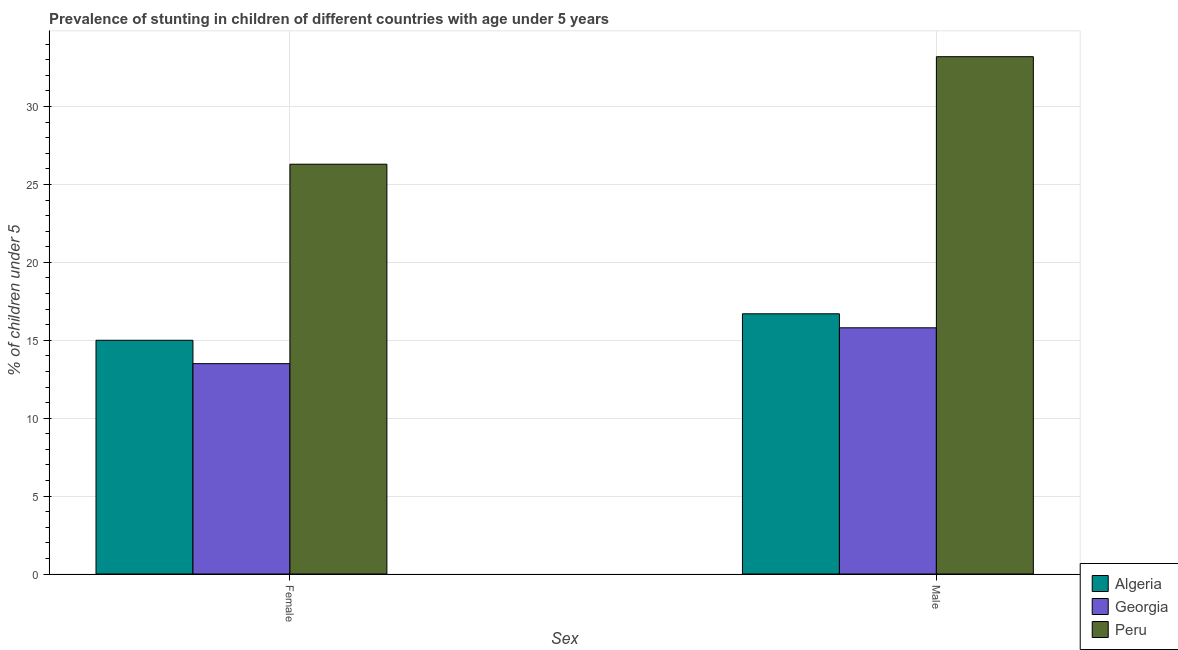How many different coloured bars are there?
Give a very brief answer. 3. How many bars are there on the 1st tick from the left?
Provide a short and direct response. 3. What is the label of the 2nd group of bars from the left?
Provide a short and direct response. Male. What is the percentage of stunted male children in Peru?
Offer a very short reply. 33.2. Across all countries, what is the maximum percentage of stunted female children?
Provide a short and direct response. 26.3. Across all countries, what is the minimum percentage of stunted male children?
Your answer should be very brief. 15.8. In which country was the percentage of stunted male children maximum?
Your answer should be very brief. Peru. In which country was the percentage of stunted female children minimum?
Your answer should be very brief. Georgia. What is the total percentage of stunted male children in the graph?
Keep it short and to the point. 65.7. What is the difference between the percentage of stunted female children in Georgia and that in Peru?
Ensure brevity in your answer.  -12.8. What is the difference between the percentage of stunted female children in Georgia and the percentage of stunted male children in Peru?
Provide a short and direct response. -19.7. What is the average percentage of stunted female children per country?
Offer a very short reply. 18.27. What is the difference between the percentage of stunted male children and percentage of stunted female children in Peru?
Offer a terse response. 6.9. In how many countries, is the percentage of stunted male children greater than 22 %?
Your response must be concise. 1. What is the ratio of the percentage of stunted female children in Algeria to that in Peru?
Offer a terse response. 0.57. In how many countries, is the percentage of stunted male children greater than the average percentage of stunted male children taken over all countries?
Keep it short and to the point. 1. What does the 1st bar from the left in Male represents?
Offer a very short reply. Algeria. What does the 2nd bar from the right in Male represents?
Your answer should be very brief. Georgia. How many bars are there?
Ensure brevity in your answer.  6. Are all the bars in the graph horizontal?
Your response must be concise. No. What is the difference between two consecutive major ticks on the Y-axis?
Your answer should be very brief. 5. Does the graph contain grids?
Provide a short and direct response. Yes. How are the legend labels stacked?
Ensure brevity in your answer.  Vertical. What is the title of the graph?
Your answer should be very brief. Prevalence of stunting in children of different countries with age under 5 years. What is the label or title of the X-axis?
Ensure brevity in your answer.  Sex. What is the label or title of the Y-axis?
Give a very brief answer.  % of children under 5. What is the  % of children under 5 of Peru in Female?
Keep it short and to the point. 26.3. What is the  % of children under 5 of Algeria in Male?
Your response must be concise. 16.7. What is the  % of children under 5 in Georgia in Male?
Ensure brevity in your answer.  15.8. What is the  % of children under 5 of Peru in Male?
Provide a succinct answer. 33.2. Across all Sex, what is the maximum  % of children under 5 in Algeria?
Make the answer very short. 16.7. Across all Sex, what is the maximum  % of children under 5 of Georgia?
Provide a succinct answer. 15.8. Across all Sex, what is the maximum  % of children under 5 of Peru?
Provide a succinct answer. 33.2. Across all Sex, what is the minimum  % of children under 5 of Algeria?
Offer a terse response. 15. Across all Sex, what is the minimum  % of children under 5 of Georgia?
Provide a succinct answer. 13.5. Across all Sex, what is the minimum  % of children under 5 of Peru?
Your answer should be compact. 26.3. What is the total  % of children under 5 in Algeria in the graph?
Keep it short and to the point. 31.7. What is the total  % of children under 5 in Georgia in the graph?
Your response must be concise. 29.3. What is the total  % of children under 5 of Peru in the graph?
Your response must be concise. 59.5. What is the difference between the  % of children under 5 of Algeria in Female and the  % of children under 5 of Georgia in Male?
Your answer should be compact. -0.8. What is the difference between the  % of children under 5 in Algeria in Female and the  % of children under 5 in Peru in Male?
Your answer should be compact. -18.2. What is the difference between the  % of children under 5 of Georgia in Female and the  % of children under 5 of Peru in Male?
Keep it short and to the point. -19.7. What is the average  % of children under 5 of Algeria per Sex?
Provide a succinct answer. 15.85. What is the average  % of children under 5 in Georgia per Sex?
Your answer should be compact. 14.65. What is the average  % of children under 5 of Peru per Sex?
Ensure brevity in your answer.  29.75. What is the difference between the  % of children under 5 of Algeria and  % of children under 5 of Georgia in Female?
Ensure brevity in your answer.  1.5. What is the difference between the  % of children under 5 of Algeria and  % of children under 5 of Peru in Female?
Your response must be concise. -11.3. What is the difference between the  % of children under 5 in Algeria and  % of children under 5 in Georgia in Male?
Keep it short and to the point. 0.9. What is the difference between the  % of children under 5 in Algeria and  % of children under 5 in Peru in Male?
Offer a terse response. -16.5. What is the difference between the  % of children under 5 of Georgia and  % of children under 5 of Peru in Male?
Keep it short and to the point. -17.4. What is the ratio of the  % of children under 5 of Algeria in Female to that in Male?
Your answer should be compact. 0.9. What is the ratio of the  % of children under 5 of Georgia in Female to that in Male?
Your answer should be very brief. 0.85. What is the ratio of the  % of children under 5 in Peru in Female to that in Male?
Offer a terse response. 0.79. What is the difference between the highest and the second highest  % of children under 5 in Algeria?
Give a very brief answer. 1.7. What is the difference between the highest and the second highest  % of children under 5 in Georgia?
Offer a very short reply. 2.3. 